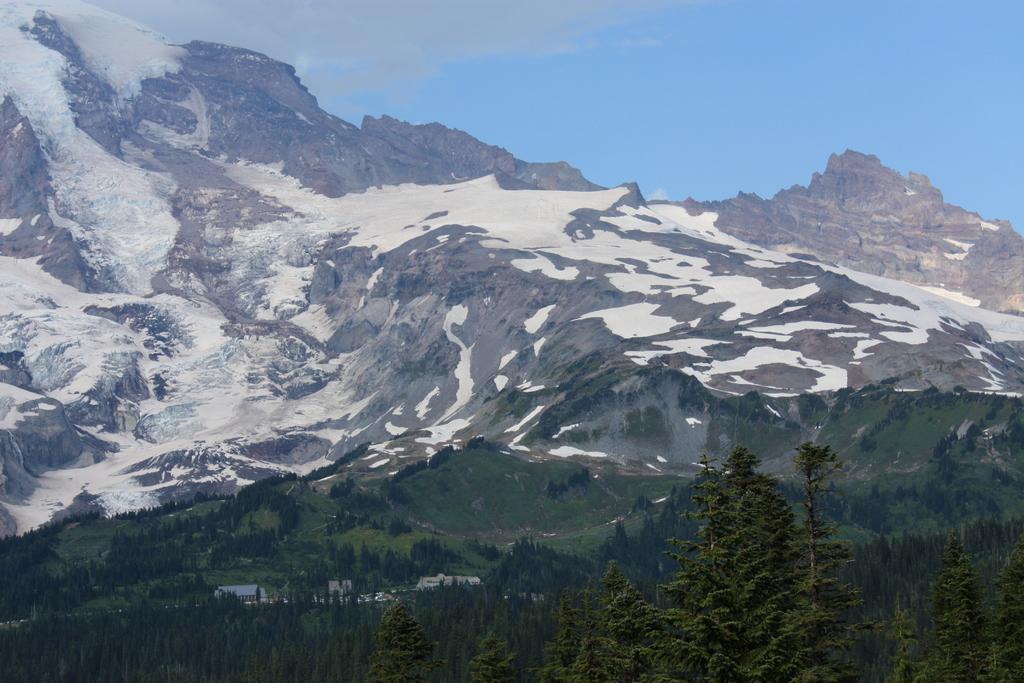In one or two sentences, can you explain what this image depicts? In the picture I can see few trees and buildings and there are few mountains covered with snow in the background. 